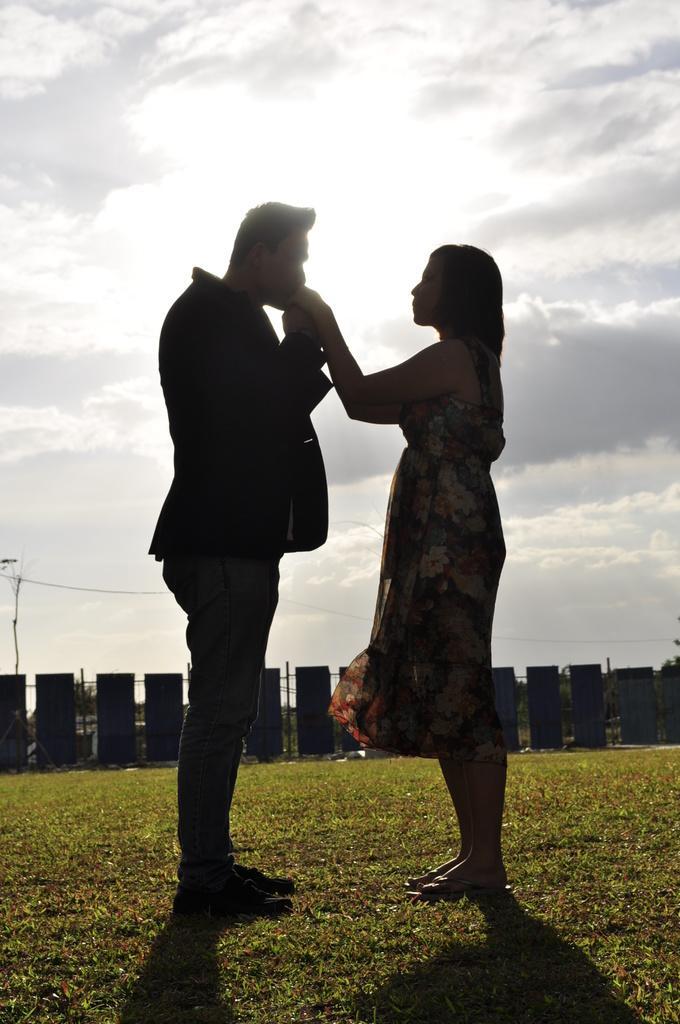Could you give a brief overview of what you see in this image? In this image there are persons standing in the center. The man on the left side is standing and holding a hand of the woman who is standing in front of him. In the background there is fence and on the ground there is grass and the sky is cloudy. 